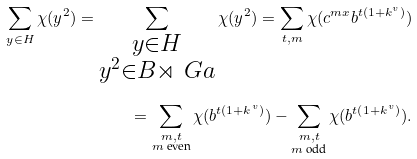<formula> <loc_0><loc_0><loc_500><loc_500>\sum _ { y \in H } \chi ( y ^ { 2 } ) = \sum _ { \substack { y \in H \\ y ^ { 2 } \in B \rtimes \ G a } } \chi ( y ^ { 2 } ) = \sum _ { t , m } \chi ( c ^ { m x } b ^ { t ( 1 + k ^ { v } ) } ) \\ = \sum _ { \substack { m , t \\ m \text { even} } } \chi ( b ^ { t ( 1 + k ^ { v } ) } ) - \sum _ { \substack { m , t \\ m \text { odd} } } \chi ( b ^ { t ( 1 + k ^ { v } ) } ) .</formula> 